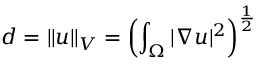Convert formula to latex. <formula><loc_0><loc_0><loc_500><loc_500>d = \| u \| _ { V } = \left ( \int _ { \Omega } | \nabla u | ^ { 2 } \right ) ^ { \frac { 1 } { 2 } }</formula> 